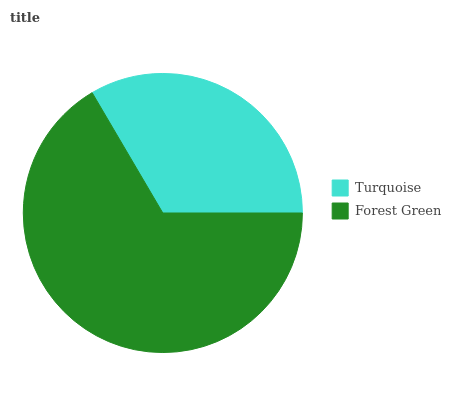Is Turquoise the minimum?
Answer yes or no. Yes. Is Forest Green the maximum?
Answer yes or no. Yes. Is Forest Green the minimum?
Answer yes or no. No. Is Forest Green greater than Turquoise?
Answer yes or no. Yes. Is Turquoise less than Forest Green?
Answer yes or no. Yes. Is Turquoise greater than Forest Green?
Answer yes or no. No. Is Forest Green less than Turquoise?
Answer yes or no. No. Is Forest Green the high median?
Answer yes or no. Yes. Is Turquoise the low median?
Answer yes or no. Yes. Is Turquoise the high median?
Answer yes or no. No. Is Forest Green the low median?
Answer yes or no. No. 